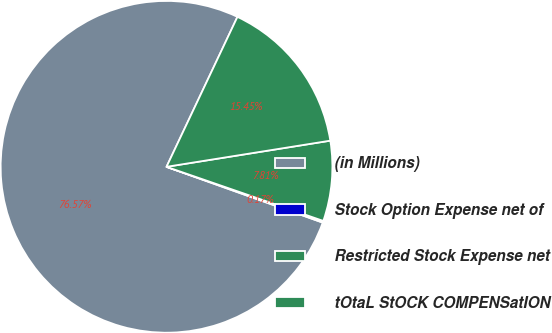Convert chart. <chart><loc_0><loc_0><loc_500><loc_500><pie_chart><fcel>(in Millions)<fcel>Stock Option Expense net of<fcel>Restricted Stock Expense net<fcel>tOtaL StOCK COMPENSatION<nl><fcel>76.58%<fcel>0.17%<fcel>7.81%<fcel>15.45%<nl></chart> 